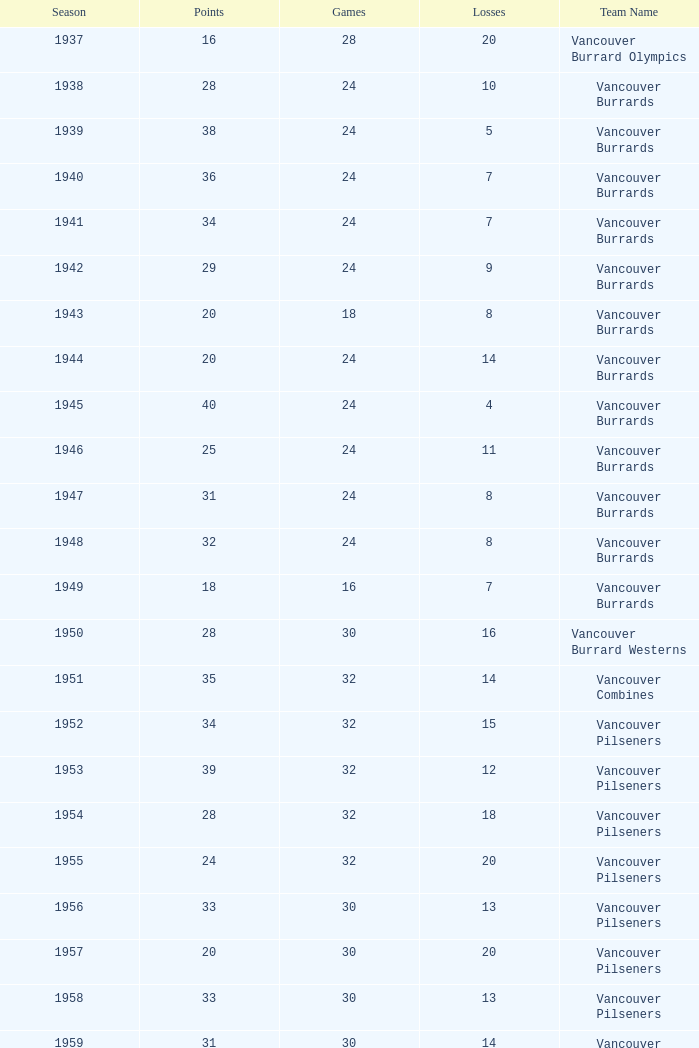What's the total number of games with more than 20 points for the 1976 season? 0.0. 